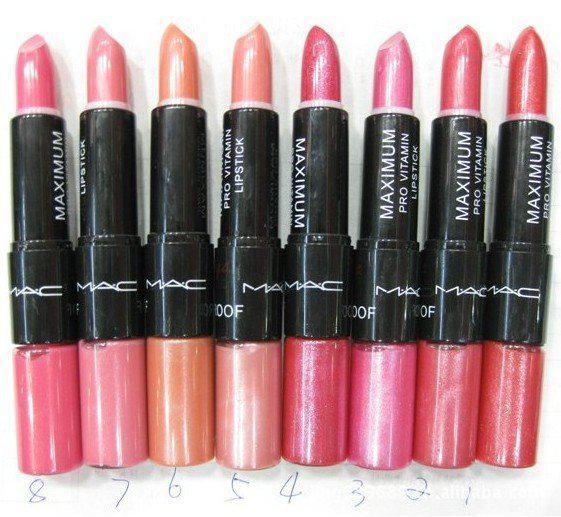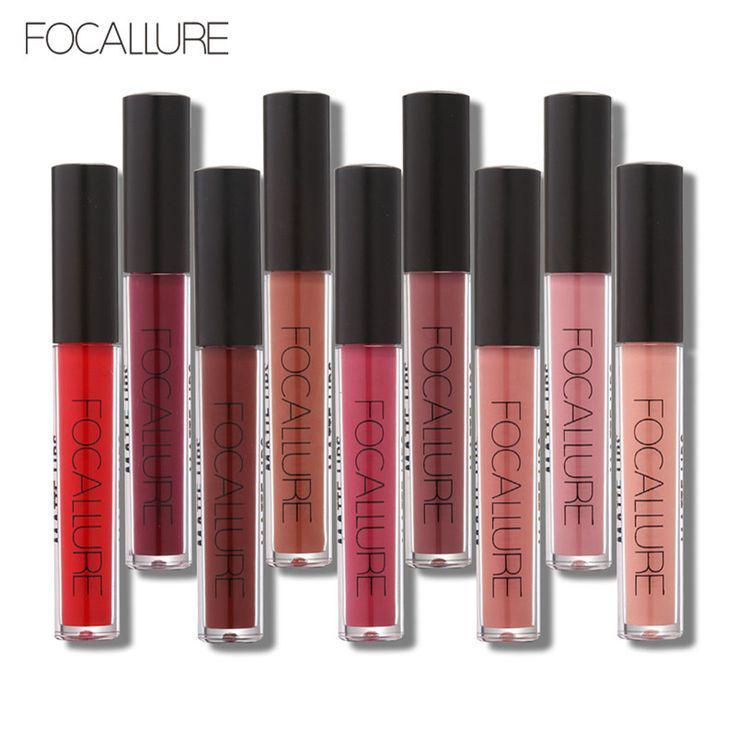The first image is the image on the left, the second image is the image on the right. Assess this claim about the two images: "Right image shows two horizontal rows of the same product style.". Correct or not? Answer yes or no. No. 